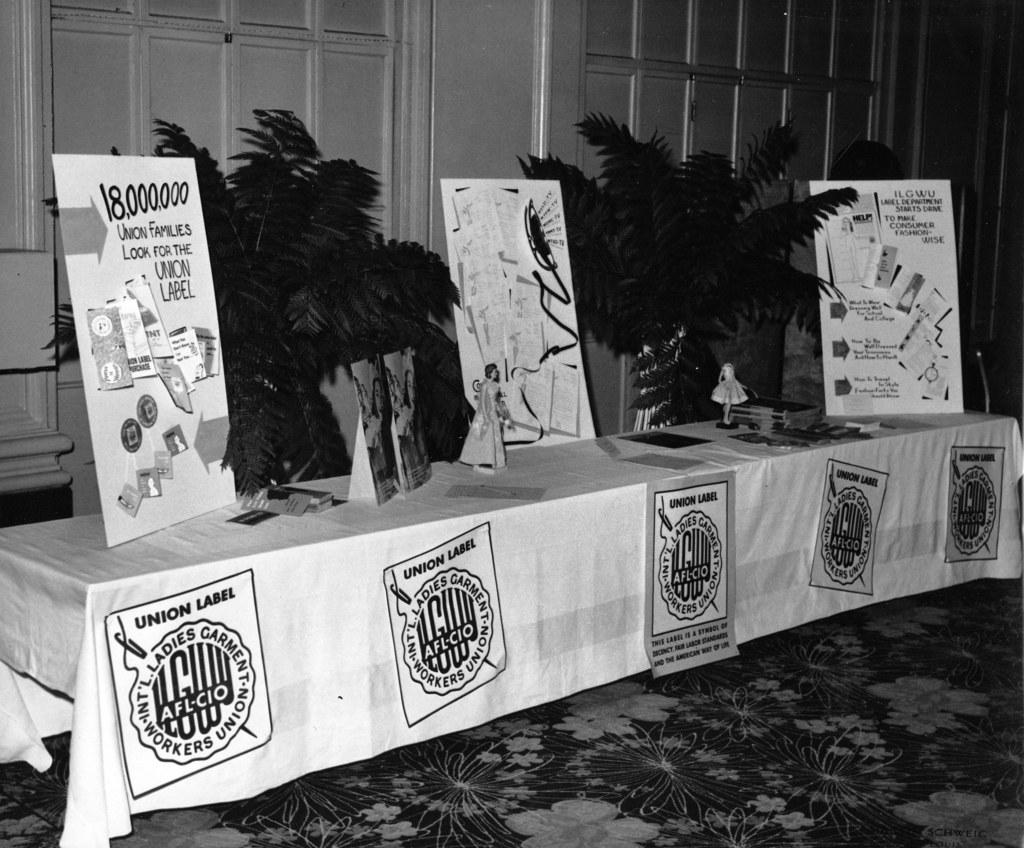<image>
Relay a brief, clear account of the picture shown. a table with poster for the Ladies Garment Workers Union 